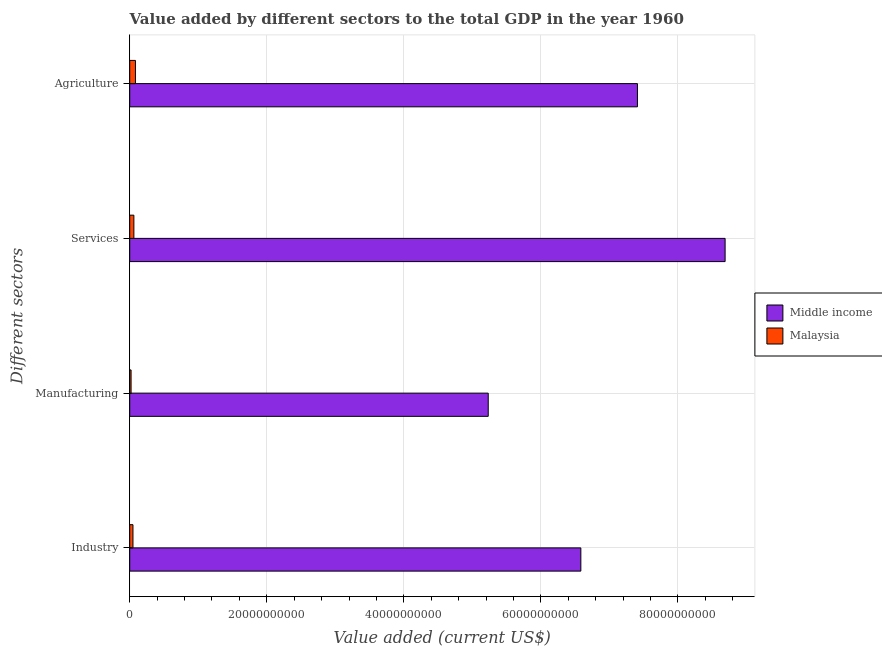Are the number of bars per tick equal to the number of legend labels?
Provide a succinct answer. Yes. Are the number of bars on each tick of the Y-axis equal?
Offer a terse response. Yes. What is the label of the 2nd group of bars from the top?
Your answer should be compact. Services. What is the value added by manufacturing sector in Malaysia?
Provide a succinct answer. 1.97e+08. Across all countries, what is the maximum value added by manufacturing sector?
Your response must be concise. 5.23e+1. Across all countries, what is the minimum value added by manufacturing sector?
Ensure brevity in your answer.  1.97e+08. In which country was the value added by manufacturing sector minimum?
Give a very brief answer. Malaysia. What is the total value added by services sector in the graph?
Keep it short and to the point. 8.75e+1. What is the difference between the value added by manufacturing sector in Malaysia and that in Middle income?
Give a very brief answer. -5.21e+1. What is the difference between the value added by manufacturing sector in Malaysia and the value added by agricultural sector in Middle income?
Keep it short and to the point. -7.39e+1. What is the average value added by manufacturing sector per country?
Offer a very short reply. 2.63e+1. What is the difference between the value added by services sector and value added by manufacturing sector in Malaysia?
Provide a succinct answer. 4.08e+08. What is the ratio of the value added by agricultural sector in Malaysia to that in Middle income?
Make the answer very short. 0.01. Is the value added by manufacturing sector in Malaysia less than that in Middle income?
Your response must be concise. Yes. Is the difference between the value added by services sector in Malaysia and Middle income greater than the difference between the value added by manufacturing sector in Malaysia and Middle income?
Your answer should be very brief. No. What is the difference between the highest and the second highest value added by services sector?
Your response must be concise. 8.63e+1. What is the difference between the highest and the lowest value added by agricultural sector?
Offer a terse response. 7.33e+1. Is it the case that in every country, the sum of the value added by services sector and value added by manufacturing sector is greater than the sum of value added by agricultural sector and value added by industrial sector?
Ensure brevity in your answer.  No. What does the 2nd bar from the top in Agriculture represents?
Offer a very short reply. Middle income. What does the 2nd bar from the bottom in Industry represents?
Your response must be concise. Malaysia. How many bars are there?
Keep it short and to the point. 8. Are all the bars in the graph horizontal?
Provide a short and direct response. Yes. How many countries are there in the graph?
Your answer should be compact. 2. What is the difference between two consecutive major ticks on the X-axis?
Offer a very short reply. 2.00e+1. How many legend labels are there?
Ensure brevity in your answer.  2. How are the legend labels stacked?
Keep it short and to the point. Vertical. What is the title of the graph?
Ensure brevity in your answer.  Value added by different sectors to the total GDP in the year 1960. Does "Senegal" appear as one of the legend labels in the graph?
Offer a terse response. No. What is the label or title of the X-axis?
Give a very brief answer. Value added (current US$). What is the label or title of the Y-axis?
Ensure brevity in your answer.  Different sectors. What is the Value added (current US$) of Middle income in Industry?
Provide a short and direct response. 6.58e+1. What is the Value added (current US$) in Malaysia in Industry?
Offer a terse response. 4.74e+08. What is the Value added (current US$) in Middle income in Manufacturing?
Ensure brevity in your answer.  5.23e+1. What is the Value added (current US$) in Malaysia in Manufacturing?
Provide a succinct answer. 1.97e+08. What is the Value added (current US$) in Middle income in Services?
Offer a very short reply. 8.69e+1. What is the Value added (current US$) in Malaysia in Services?
Ensure brevity in your answer.  6.05e+08. What is the Value added (current US$) of Middle income in Agriculture?
Provide a short and direct response. 7.41e+1. What is the Value added (current US$) in Malaysia in Agriculture?
Your answer should be very brief. 8.38e+08. Across all Different sectors, what is the maximum Value added (current US$) in Middle income?
Provide a succinct answer. 8.69e+1. Across all Different sectors, what is the maximum Value added (current US$) in Malaysia?
Provide a short and direct response. 8.38e+08. Across all Different sectors, what is the minimum Value added (current US$) of Middle income?
Keep it short and to the point. 5.23e+1. Across all Different sectors, what is the minimum Value added (current US$) in Malaysia?
Offer a very short reply. 1.97e+08. What is the total Value added (current US$) in Middle income in the graph?
Your response must be concise. 2.79e+11. What is the total Value added (current US$) in Malaysia in the graph?
Give a very brief answer. 2.11e+09. What is the difference between the Value added (current US$) in Middle income in Industry and that in Manufacturing?
Keep it short and to the point. 1.35e+1. What is the difference between the Value added (current US$) in Malaysia in Industry and that in Manufacturing?
Your answer should be compact. 2.77e+08. What is the difference between the Value added (current US$) in Middle income in Industry and that in Services?
Offer a very short reply. -2.11e+1. What is the difference between the Value added (current US$) in Malaysia in Industry and that in Services?
Ensure brevity in your answer.  -1.31e+08. What is the difference between the Value added (current US$) of Middle income in Industry and that in Agriculture?
Your answer should be compact. -8.26e+09. What is the difference between the Value added (current US$) of Malaysia in Industry and that in Agriculture?
Keep it short and to the point. -3.64e+08. What is the difference between the Value added (current US$) in Middle income in Manufacturing and that in Services?
Your response must be concise. -3.46e+1. What is the difference between the Value added (current US$) in Malaysia in Manufacturing and that in Services?
Your response must be concise. -4.08e+08. What is the difference between the Value added (current US$) in Middle income in Manufacturing and that in Agriculture?
Give a very brief answer. -2.18e+1. What is the difference between the Value added (current US$) of Malaysia in Manufacturing and that in Agriculture?
Make the answer very short. -6.41e+08. What is the difference between the Value added (current US$) of Middle income in Services and that in Agriculture?
Ensure brevity in your answer.  1.28e+1. What is the difference between the Value added (current US$) of Malaysia in Services and that in Agriculture?
Provide a short and direct response. -2.33e+08. What is the difference between the Value added (current US$) in Middle income in Industry and the Value added (current US$) in Malaysia in Manufacturing?
Ensure brevity in your answer.  6.56e+1. What is the difference between the Value added (current US$) of Middle income in Industry and the Value added (current US$) of Malaysia in Services?
Make the answer very short. 6.52e+1. What is the difference between the Value added (current US$) of Middle income in Industry and the Value added (current US$) of Malaysia in Agriculture?
Ensure brevity in your answer.  6.50e+1. What is the difference between the Value added (current US$) of Middle income in Manufacturing and the Value added (current US$) of Malaysia in Services?
Provide a succinct answer. 5.17e+1. What is the difference between the Value added (current US$) of Middle income in Manufacturing and the Value added (current US$) of Malaysia in Agriculture?
Your answer should be very brief. 5.15e+1. What is the difference between the Value added (current US$) in Middle income in Services and the Value added (current US$) in Malaysia in Agriculture?
Your response must be concise. 8.60e+1. What is the average Value added (current US$) in Middle income per Different sectors?
Your answer should be very brief. 6.98e+1. What is the average Value added (current US$) in Malaysia per Different sectors?
Give a very brief answer. 5.28e+08. What is the difference between the Value added (current US$) of Middle income and Value added (current US$) of Malaysia in Industry?
Provide a short and direct response. 6.54e+1. What is the difference between the Value added (current US$) of Middle income and Value added (current US$) of Malaysia in Manufacturing?
Offer a terse response. 5.21e+1. What is the difference between the Value added (current US$) in Middle income and Value added (current US$) in Malaysia in Services?
Provide a short and direct response. 8.63e+1. What is the difference between the Value added (current US$) of Middle income and Value added (current US$) of Malaysia in Agriculture?
Ensure brevity in your answer.  7.33e+1. What is the ratio of the Value added (current US$) in Middle income in Industry to that in Manufacturing?
Keep it short and to the point. 1.26. What is the ratio of the Value added (current US$) of Malaysia in Industry to that in Manufacturing?
Your answer should be compact. 2.41. What is the ratio of the Value added (current US$) in Middle income in Industry to that in Services?
Offer a terse response. 0.76. What is the ratio of the Value added (current US$) of Malaysia in Industry to that in Services?
Your response must be concise. 0.78. What is the ratio of the Value added (current US$) in Middle income in Industry to that in Agriculture?
Ensure brevity in your answer.  0.89. What is the ratio of the Value added (current US$) of Malaysia in Industry to that in Agriculture?
Your response must be concise. 0.57. What is the ratio of the Value added (current US$) of Middle income in Manufacturing to that in Services?
Your response must be concise. 0.6. What is the ratio of the Value added (current US$) of Malaysia in Manufacturing to that in Services?
Make the answer very short. 0.33. What is the ratio of the Value added (current US$) of Middle income in Manufacturing to that in Agriculture?
Make the answer very short. 0.71. What is the ratio of the Value added (current US$) of Malaysia in Manufacturing to that in Agriculture?
Make the answer very short. 0.23. What is the ratio of the Value added (current US$) of Middle income in Services to that in Agriculture?
Your answer should be compact. 1.17. What is the ratio of the Value added (current US$) in Malaysia in Services to that in Agriculture?
Give a very brief answer. 0.72. What is the difference between the highest and the second highest Value added (current US$) in Middle income?
Your answer should be very brief. 1.28e+1. What is the difference between the highest and the second highest Value added (current US$) of Malaysia?
Your answer should be very brief. 2.33e+08. What is the difference between the highest and the lowest Value added (current US$) in Middle income?
Your answer should be very brief. 3.46e+1. What is the difference between the highest and the lowest Value added (current US$) in Malaysia?
Your response must be concise. 6.41e+08. 